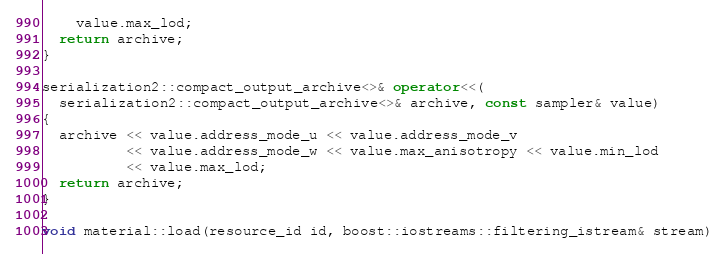Convert code to text. <code><loc_0><loc_0><loc_500><loc_500><_C++_>    value.max_lod;
  return archive;
}

serialization2::compact_output_archive<>& operator<<(
  serialization2::compact_output_archive<>& archive, const sampler& value)
{
  archive << value.address_mode_u << value.address_mode_v
          << value.address_mode_w << value.max_anisotropy << value.min_lod
          << value.max_lod;
  return archive;
}

void material::load(resource_id id, boost::iostreams::filtering_istream& stream)</code> 